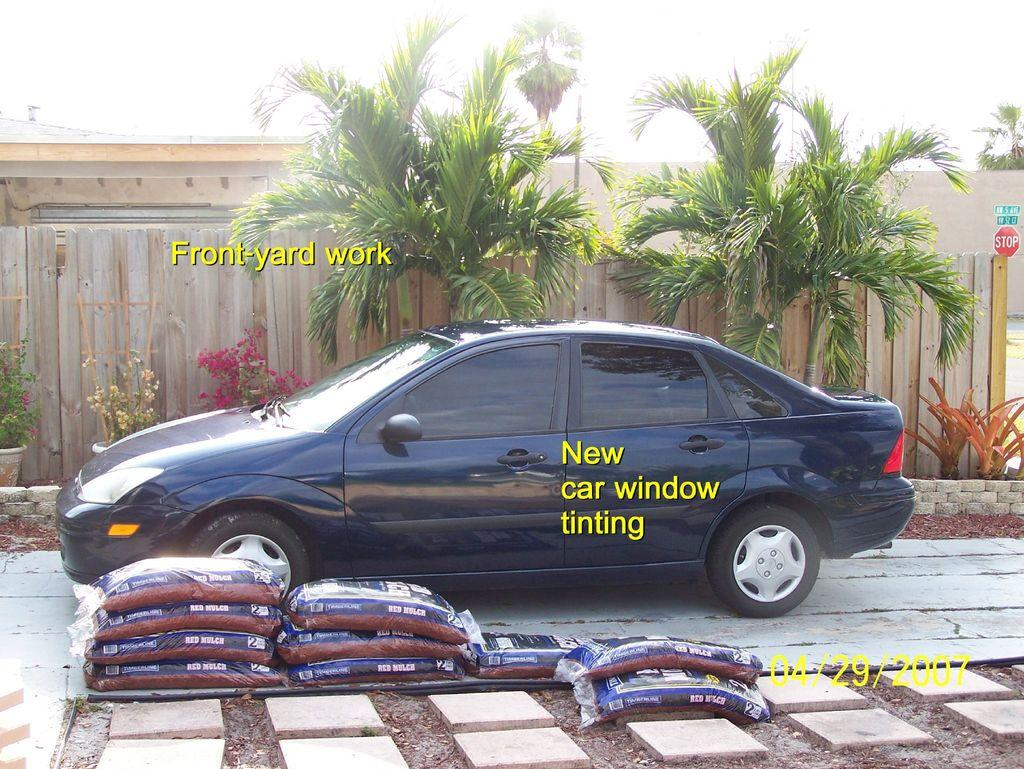<image>
Create a compact narrative representing the image presented. Front yard work and new car window tinting is being shown off. 